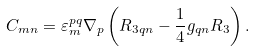<formula> <loc_0><loc_0><loc_500><loc_500>C _ { m n } = \varepsilon _ { m } ^ { p q } \nabla _ { p } \left ( R _ { 3 q n } - \frac { 1 } { 4 } g _ { q n } R _ { 3 } \right ) .</formula> 